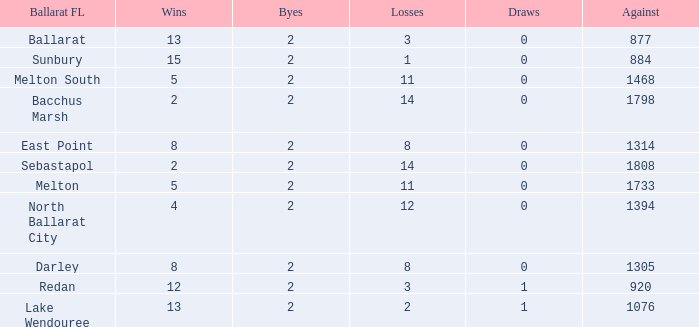How many Against has a Ballarat FL of darley and Wins larger than 8? 0.0. 